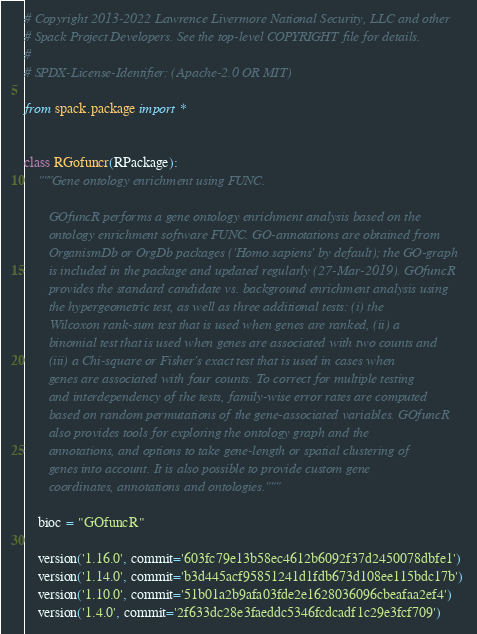Convert code to text. <code><loc_0><loc_0><loc_500><loc_500><_Python_># Copyright 2013-2022 Lawrence Livermore National Security, LLC and other
# Spack Project Developers. See the top-level COPYRIGHT file for details.
#
# SPDX-License-Identifier: (Apache-2.0 OR MIT)

from spack.package import *


class RGofuncr(RPackage):
    """Gene ontology enrichment using FUNC.

       GOfuncR performs a gene ontology enrichment analysis based on the
       ontology enrichment software FUNC. GO-annotations are obtained from
       OrganismDb or OrgDb packages ('Homo.sapiens' by default); the GO-graph
       is included in the package and updated regularly (27-Mar-2019). GOfuncR
       provides the standard candidate vs. background enrichment analysis using
       the hypergeometric test, as well as three additional tests: (i) the
       Wilcoxon rank-sum test that is used when genes are ranked, (ii) a
       binomial test that is used when genes are associated with two counts and
       (iii) a Chi-square or Fisher's exact test that is used in cases when
       genes are associated with four counts. To correct for multiple testing
       and interdependency of the tests, family-wise error rates are computed
       based on random permutations of the gene-associated variables. GOfuncR
       also provides tools for exploring the ontology graph and the
       annotations, and options to take gene-length or spatial clustering of
       genes into account. It is also possible to provide custom gene
       coordinates, annotations and ontologies."""

    bioc = "GOfuncR"

    version('1.16.0', commit='603fc79e13b58ec4612b6092f37d2450078dbfe1')
    version('1.14.0', commit='b3d445acf95851241d1fdb673d108ee115bdc17b')
    version('1.10.0', commit='51b01a2b9afa03fde2e1628036096cbeafaa2ef4')
    version('1.4.0', commit='2f633dc28e3faeddc5346fcdcadf1c29e3fcf709')</code> 